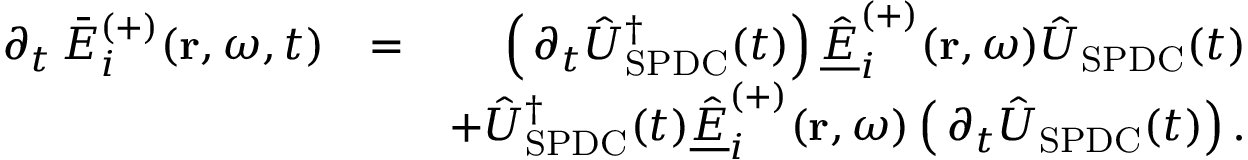<formula> <loc_0><loc_0><loc_500><loc_500>\begin{array} { r l r } { \, \partial _ { t } \, \bar { E } _ { i } ^ { ( + ) } ( r , \omega , t ) } & { = } & { \left ( \, \partial _ { t } \hat { U } _ { S P D C } ^ { \dagger } ( t ) \right ) \underline { { \hat { E } } } _ { i } ^ { ( + ) } ( r , \omega ) \hat { U } _ { S P D C } ( t ) } \\ & { + \hat { U } _ { S P D C } ^ { \dagger } ( t ) \underline { { \hat { E } } } _ { i } ^ { ( + ) } ( r , \omega ) \left ( \, \partial _ { t } \hat { U } _ { S P D C } ( t ) \right ) . } \end{array}</formula> 